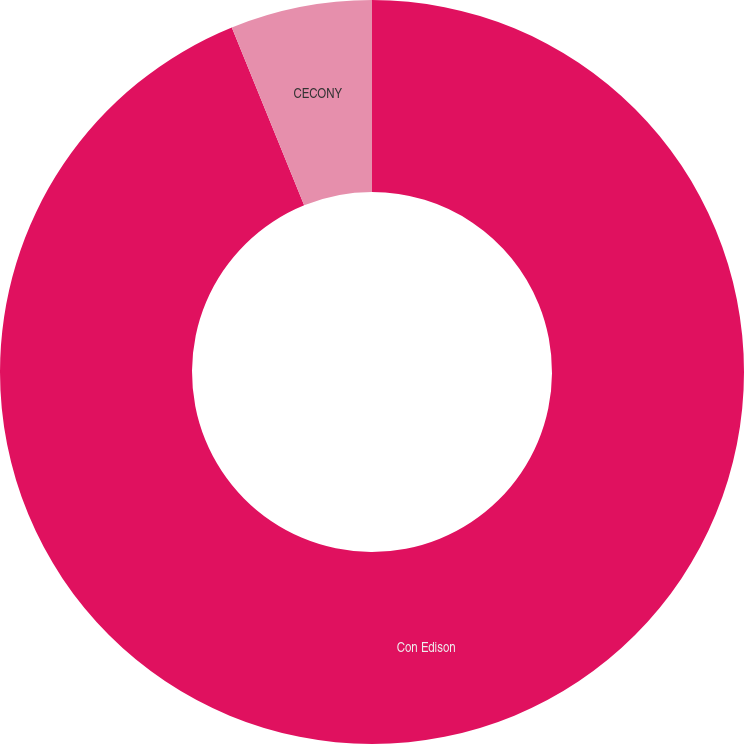Convert chart. <chart><loc_0><loc_0><loc_500><loc_500><pie_chart><fcel>Con Edison<fcel>CECONY<nl><fcel>93.85%<fcel>6.15%<nl></chart> 